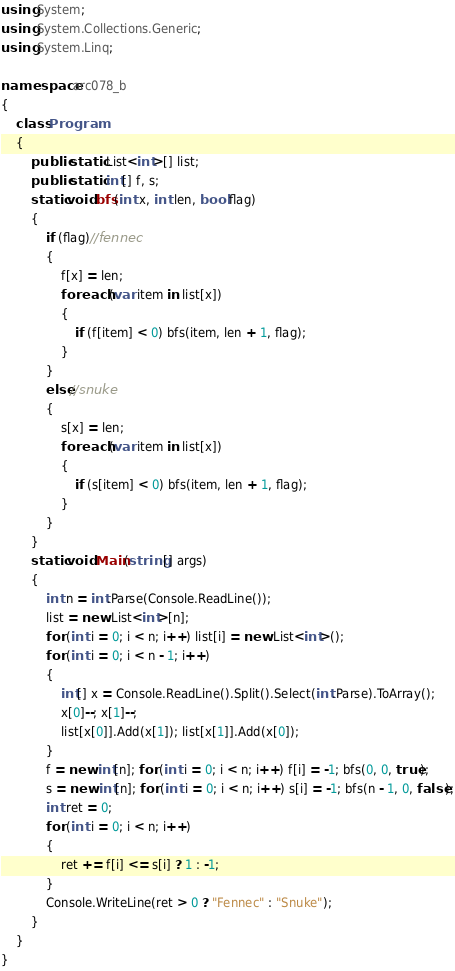Convert code to text. <code><loc_0><loc_0><loc_500><loc_500><_C#_>using System;
using System.Collections.Generic;
using System.Linq;

namespace arc078_b
{
	class Program
	{
		public static List<int>[] list;
		public static int[] f, s;
		static void bfs(int x, int len, bool flag)
		{
			if (flag)//fennec
			{
				f[x] = len;
				foreach (var item in list[x])
				{
					if (f[item] < 0) bfs(item, len + 1, flag);
				}
			}
			else//snuke
			{
				s[x] = len;
				foreach (var item in list[x])
				{
					if (s[item] < 0) bfs(item, len + 1, flag);
				}
			}
		}
		static void Main(string[] args)
		{
			int n = int.Parse(Console.ReadLine());
			list = new List<int>[n];
			for (int i = 0; i < n; i++) list[i] = new List<int>();
			for (int i = 0; i < n - 1; i++)
			{
				int[] x = Console.ReadLine().Split().Select(int.Parse).ToArray();
				x[0]--; x[1]--;
				list[x[0]].Add(x[1]); list[x[1]].Add(x[0]);
			}
			f = new int[n]; for (int i = 0; i < n; i++) f[i] = -1; bfs(0, 0, true);
			s = new int[n]; for (int i = 0; i < n; i++) s[i] = -1; bfs(n - 1, 0, false);
			int ret = 0;
			for (int i = 0; i < n; i++)
			{
				ret += f[i] <= s[i] ? 1 : -1;
			}
			Console.WriteLine(ret > 0 ? "Fennec" : "Snuke");
		}
	}
}</code> 